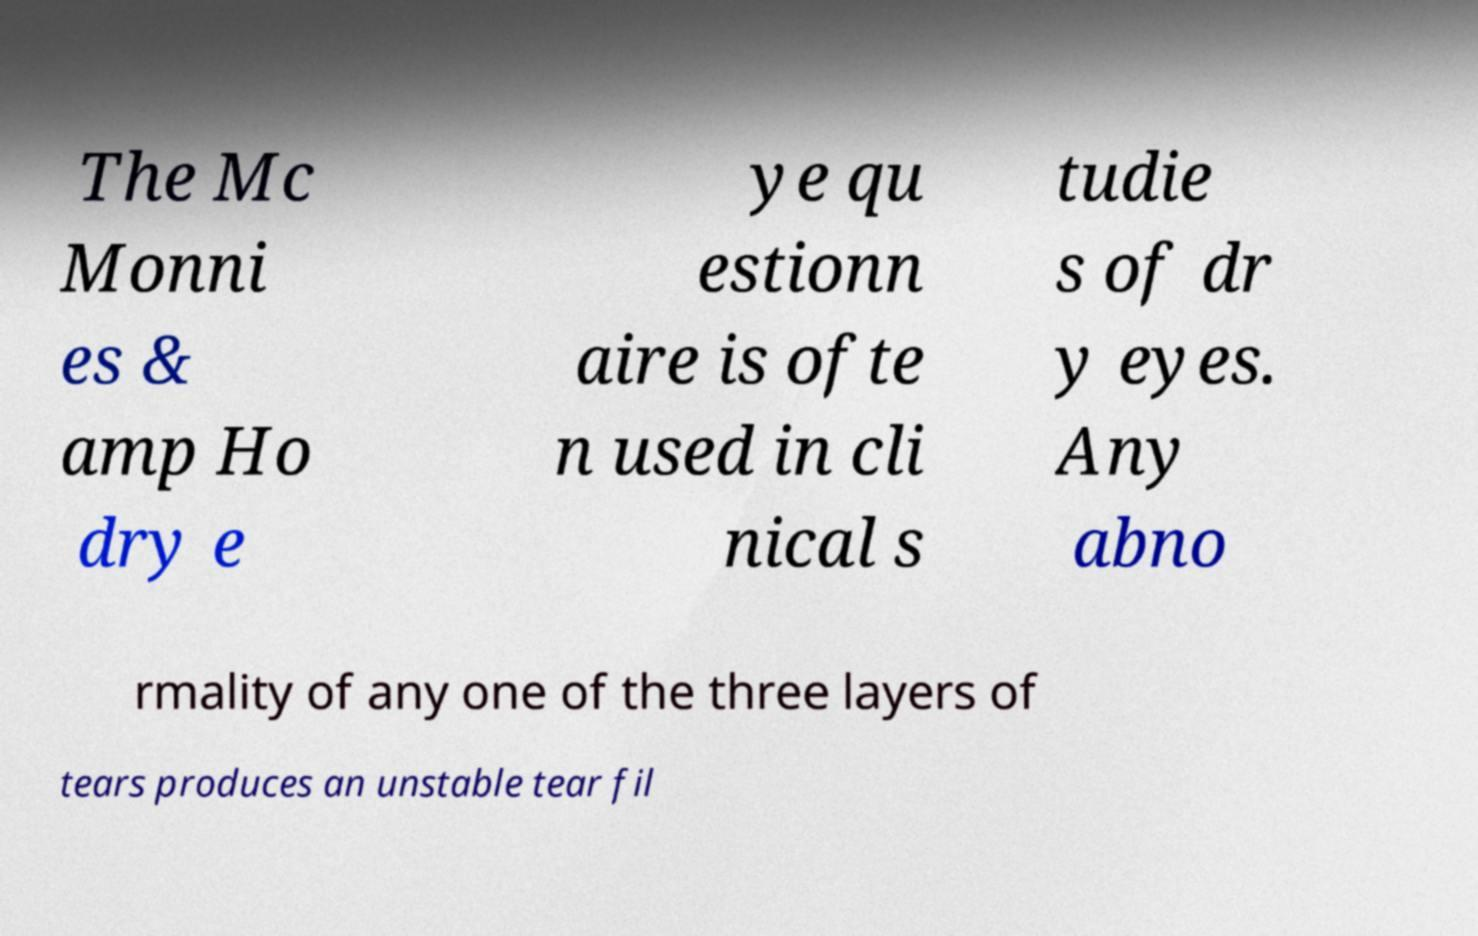Please read and relay the text visible in this image. What does it say? The Mc Monni es & amp Ho dry e ye qu estionn aire is ofte n used in cli nical s tudie s of dr y eyes. Any abno rmality of any one of the three layers of tears produces an unstable tear fil 